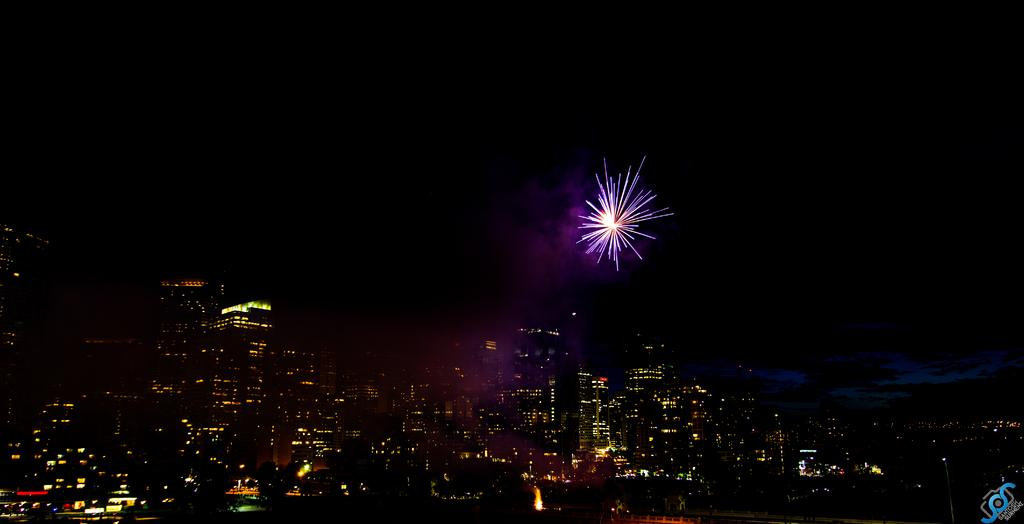What type of structure can be seen in the image? There is a bridge in the image. What other man-made structures are visible in the image? Skyscrapers are present in the image. What is happening in the sky in the image? There is a firecracker in the sky. Can you describe any additional features of the image? There is a watermark on the image. Can you tell me how the donkey is feeling in the image? There is no donkey present in the image, so it is not possible to determine how it might be feeling. 